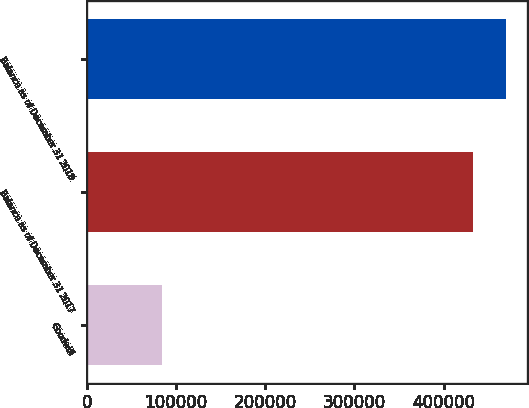Convert chart. <chart><loc_0><loc_0><loc_500><loc_500><bar_chart><fcel>Goodwill<fcel>Balance as of December 31 2017<fcel>Balance as of December 31 2018<nl><fcel>84615<fcel>433049<fcel>470146<nl></chart> 